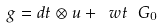Convert formula to latex. <formula><loc_0><loc_0><loc_500><loc_500>\ g = d t \otimes u + \ w t \ G _ { 0 }</formula> 